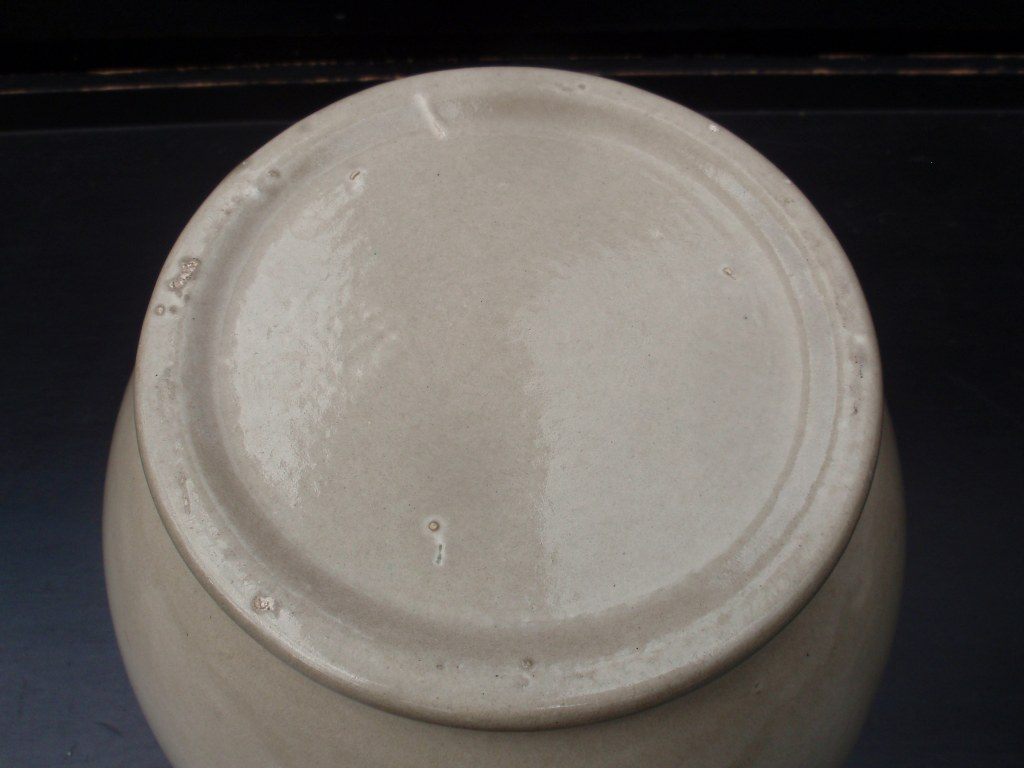Can you describe the texture of the object? The texture of the object, as seen from the image, appears to be smooth and slightly glossy. The light reflection on the surface suggests a glazed finish, commonly found on pottery or ceramic items. There are subtle imperfections or bumps that are likely due to the handmade nature of the object, giving it a unique and artisan feel. 